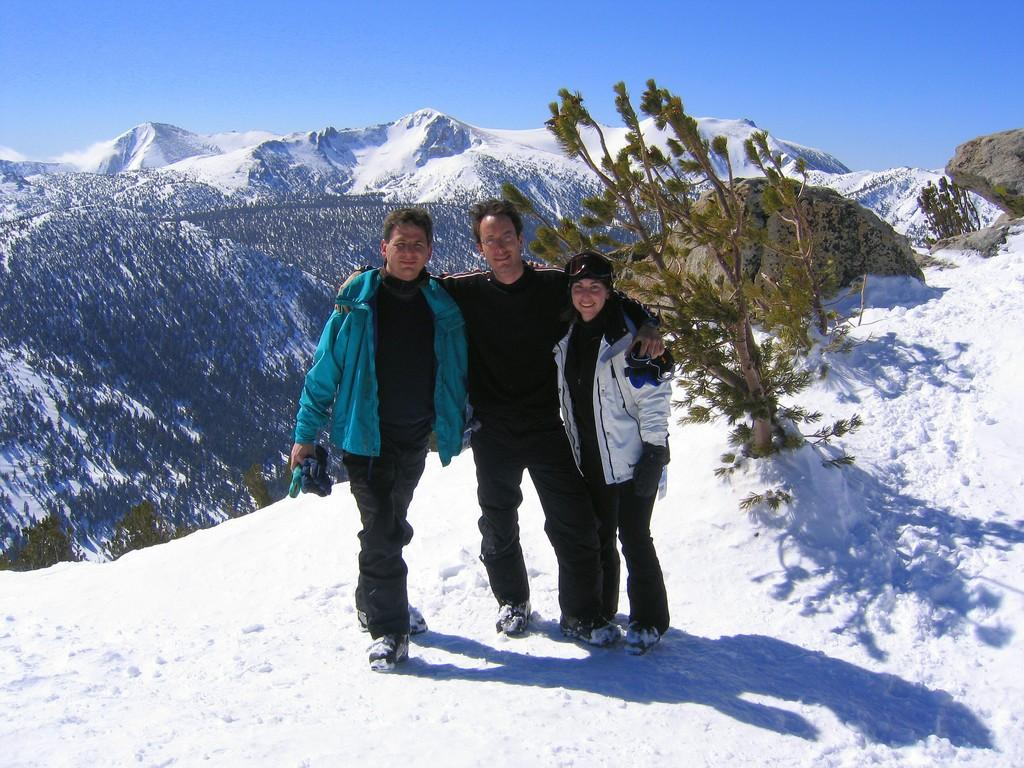How many people are in the image? There are three people in the image. What is the surface on which the people are standing? The people are standing on the surface of the snow. What can be seen behind the people? There is a tree behind the people. What is visible in the background of the image? There is a mountain and the sky in the background of the image. What is the condition of the mountain? The mountain has snow on top of it. How many pizzas are being served to the committee in the image? There are no pizzas or committee present in the image; it features three people standing on snow with a tree and a mountain in the background. Can you tell me the color of the ladybug on the tree in the image? There is no ladybug present on the tree in the image. 